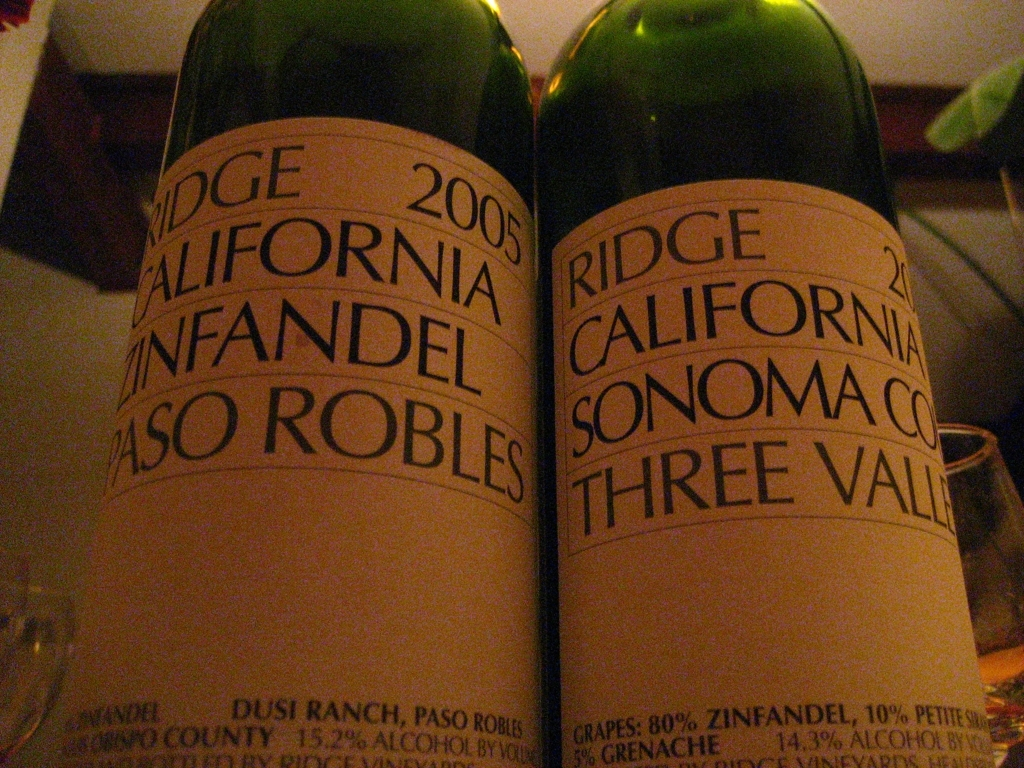Can you tell me more about the specific wine regions mentioned on these bottles? The labels mention 'Paso Robles' and 'Sonoma County,' both renowned wine regions in California. Paso Robles is known for its diverse soil types and microclimates, which is ideal for producing rich and robust Zinfandels. Sonoma County, on the other hand, has a cooler climate influenced by the Pacific Ocean, making it perfect for a variety of grapes, including Zinfandel, with a focus on creating balanced and nuanced wines. 